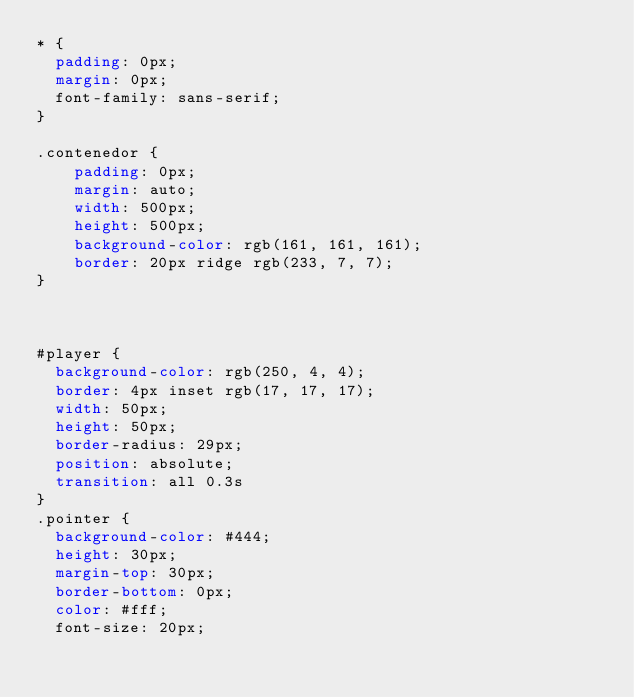<code> <loc_0><loc_0><loc_500><loc_500><_CSS_>* {
	padding: 0px;
	margin: 0px;
	font-family: sans-serif;
}

.contenedor {
    padding: 0px;
    margin: auto;
    width: 500px;
    height: 500px;
    background-color: rgb(161, 161, 161);
    border: 20px ridge rgb(233, 7, 7);
}



#player {
	background-color: rgb(250, 4, 4);
	border: 4px inset rgb(17, 17, 17);
	width: 50px;
	height: 50px;
	border-radius: 29px;
	position: absolute;
	transition: all 0.3s
}
.pointer {
	background-color: #444;
	height: 30px;
	margin-top: 30px;
	border-bottom: 0px;
	color: #fff;
	font-size: 20px;</code> 